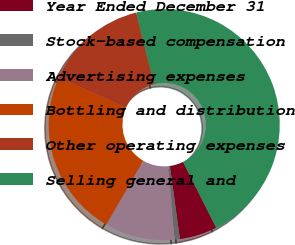Convert chart. <chart><loc_0><loc_0><loc_500><loc_500><pie_chart><fcel>Year Ended December 31<fcel>Stock-based compensation<fcel>Advertising expenses<fcel>Bottling and distribution<fcel>Other operating expenses<fcel>Selling general and<nl><fcel>5.27%<fcel>0.68%<fcel>9.85%<fcel>23.32%<fcel>14.43%<fcel>46.46%<nl></chart> 